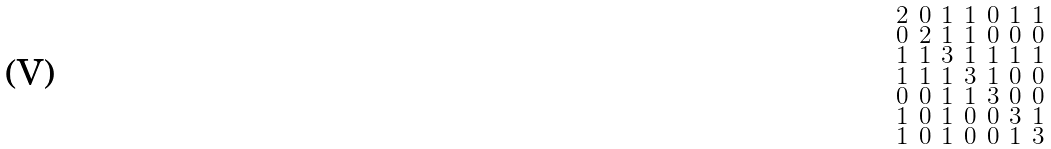<formula> <loc_0><loc_0><loc_500><loc_500>\begin{smallmatrix} 2 & 0 & 1 & 1 & 0 & 1 & 1 \\ 0 & 2 & 1 & 1 & 0 & 0 & 0 \\ 1 & 1 & 3 & 1 & 1 & 1 & 1 \\ 1 & 1 & 1 & 3 & 1 & 0 & 0 \\ 0 & 0 & 1 & 1 & 3 & 0 & 0 \\ 1 & 0 & 1 & 0 & 0 & 3 & 1 \\ 1 & 0 & 1 & 0 & 0 & 1 & 3 \end{smallmatrix}</formula> 